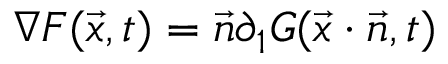Convert formula to latex. <formula><loc_0><loc_0><loc_500><loc_500>\nabla F ( { \vec { x } } , t ) = { \vec { n } } \partial _ { 1 } G ( { \vec { x } } \cdot { \vec { n } } , t )</formula> 